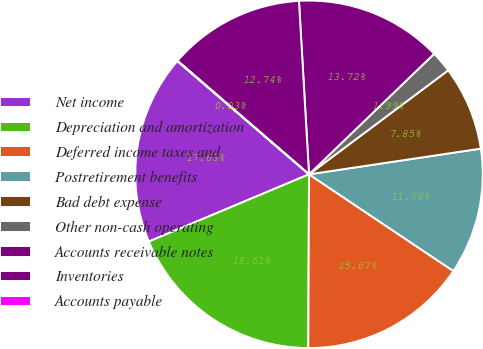Convert chart to OTSL. <chart><loc_0><loc_0><loc_500><loc_500><pie_chart><fcel>Net income<fcel>Depreciation and amortization<fcel>Deferred income taxes and<fcel>Postretirement benefits<fcel>Bad debt expense<fcel>Other non-cash operating<fcel>Accounts receivable notes<fcel>Inventories<fcel>Accounts payable<nl><fcel>17.63%<fcel>18.61%<fcel>15.67%<fcel>11.76%<fcel>7.85%<fcel>1.99%<fcel>13.72%<fcel>12.74%<fcel>0.03%<nl></chart> 